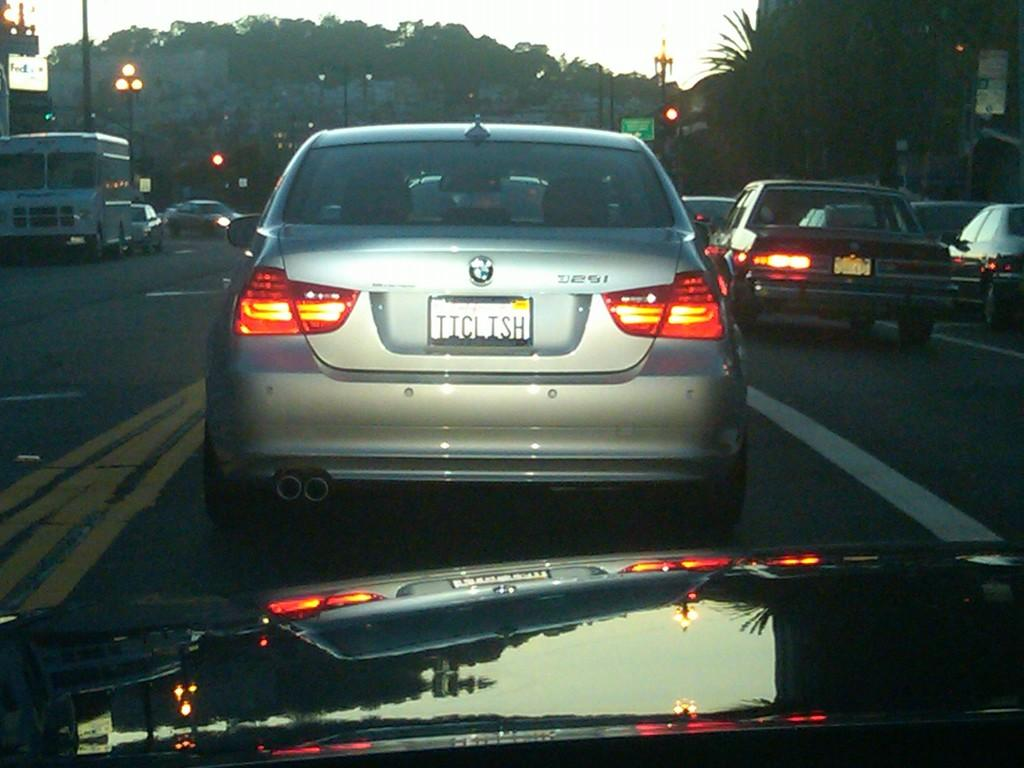Provide a one-sentence caption for the provided image. A silver BMW liscence plate is TICLISH on the back. 